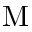<formula> <loc_0><loc_0><loc_500><loc_500>M</formula> 